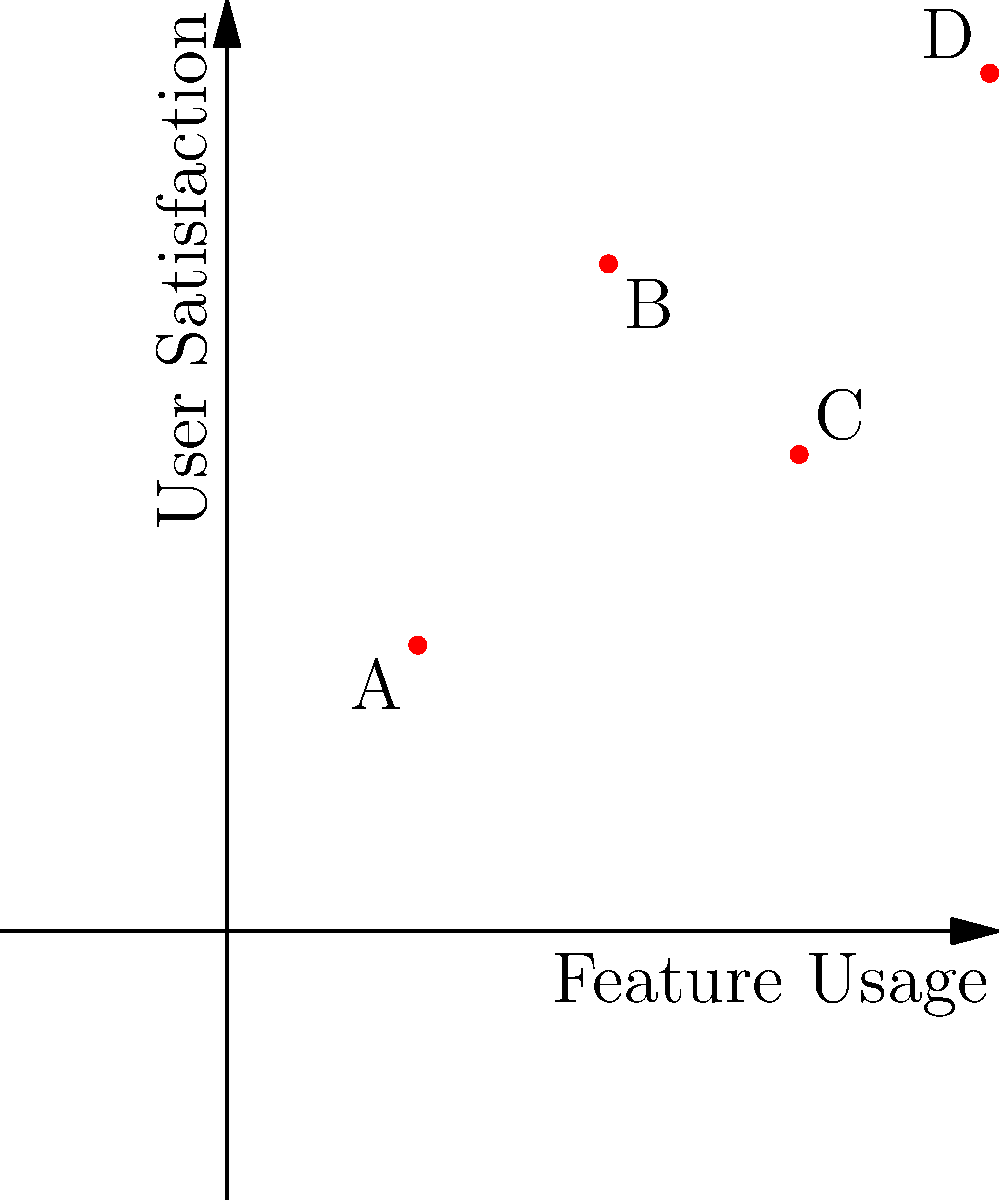Based on the scatter plot showing user satisfaction vs. feature usage for four features (A, B, C, and D) of a health tech solution, which feature should be prioritized for further development to maximize user satisfaction and usage? To determine which feature should be prioritized, we need to analyze the scatter plot and consider both user satisfaction and feature usage:

1. Feature A (0.2, 0.3): Low usage and low satisfaction
2. Feature B (0.4, 0.7): Moderate usage and high satisfaction
3. Feature C (0.6, 0.5): High usage but moderate satisfaction
4. Feature D (0.8, 0.9): High usage and high satisfaction

The ideal feature to prioritize would have high usage and high satisfaction, as this indicates it's both popular and well-received by users.

Step 1: Eliminate low-performing features
Feature A can be eliminated as it has both low usage and low satisfaction.

Step 2: Compare remaining features
Among B, C, and D:
- Feature B has high satisfaction but moderate usage
- Feature C has high usage but moderate satisfaction
- Feature D has both high usage and high satisfaction

Step 3: Identify the best candidate
Feature D stands out as the best candidate for further development because it has the highest combination of usage and satisfaction. Improving this feature is likely to have the most significant impact on overall user experience and product success.

Step 4: Consider product strategy
As a product manager, prioritizing Feature D aligns with the goal of enhancing features that are already performing well, potentially leading to even greater user satisfaction and increased usage.
Answer: Feature D 